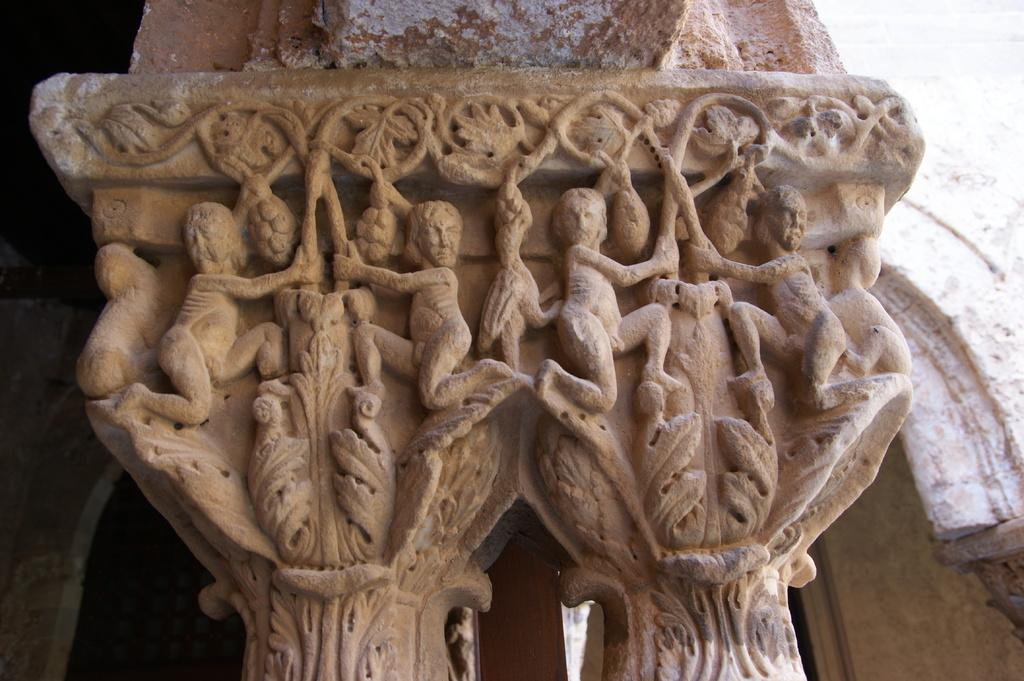What is featured on the pillar in the image? There are engravings on a pillar in the image. What else can be seen in the background of the image? There is a wall visible behind the pillar. What type of coil is wrapped around the bear in the image? There is no bear or coil present in the image; it only features a pillar with engravings and a wall in the background. 